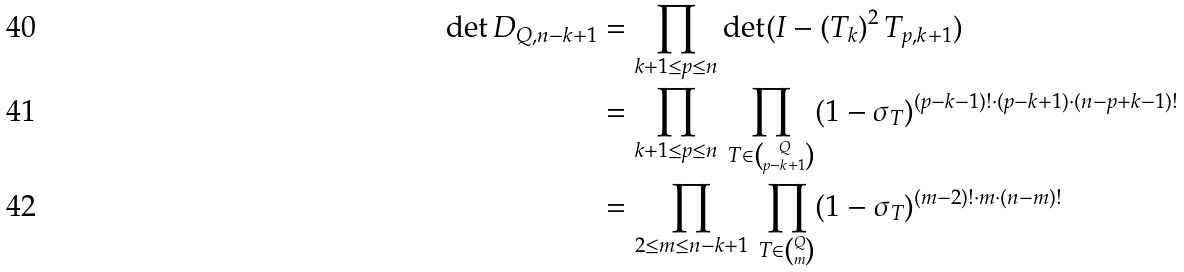Convert formula to latex. <formula><loc_0><loc_0><loc_500><loc_500>\det { D } _ { Q , n - k + 1 } & = \prod _ { k + 1 \leq p \leq n } \det ( { I } - ( { T } _ { k } ) ^ { 2 } \, { T } _ { p , k + 1 } ) \\ & = \prod _ { k + 1 \leq p \leq n } \, \prod _ { T \in { Q \choose p - k + 1 } } ( 1 - \sigma _ { T } ) ^ { ( p - k - 1 ) ! \cdot ( p - k + 1 ) \cdot ( n - p + k - 1 ) ! } \\ & = \prod _ { 2 \leq m \leq n - k + 1 } \, \prod _ { T \in { Q \choose m } } ( 1 - \sigma _ { T } ) ^ { ( m - 2 ) ! \cdot m \cdot ( n - m ) ! }</formula> 